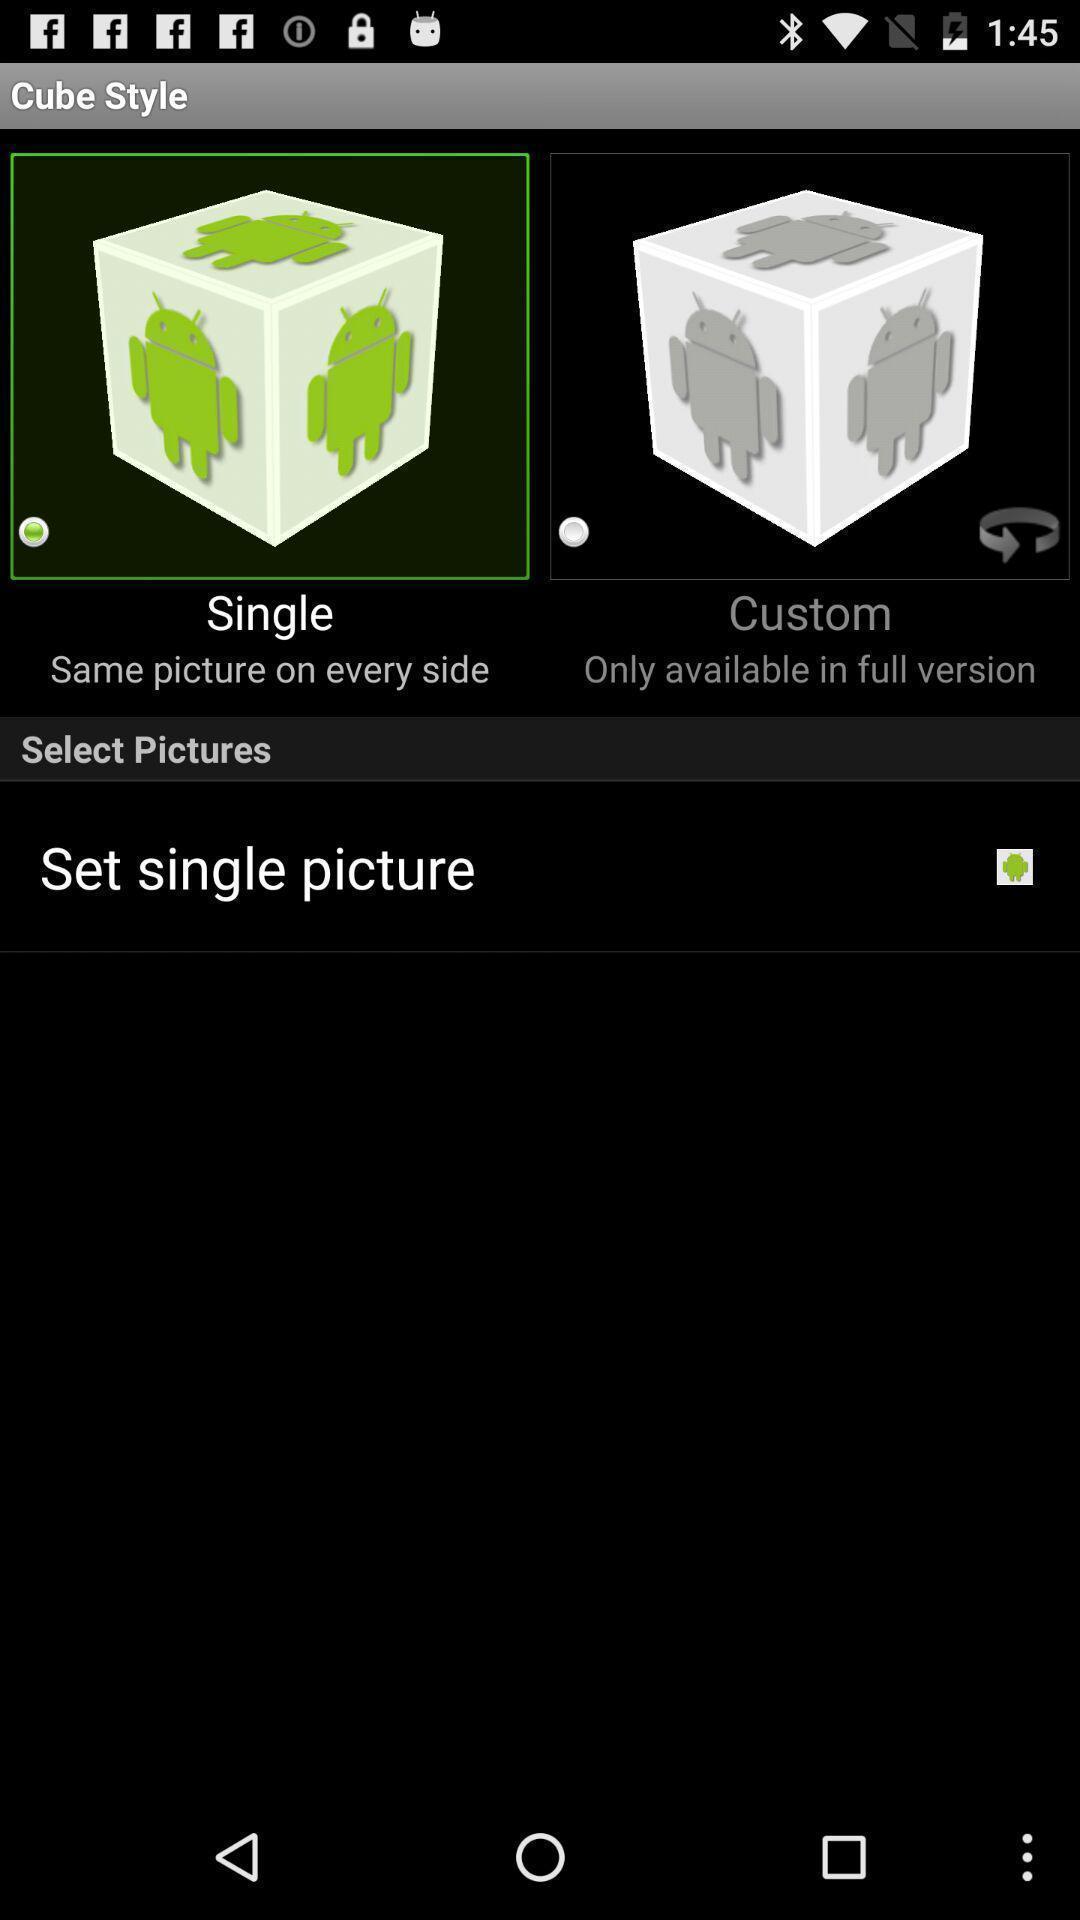Tell me about the visual elements in this screen capture. Window displaying to set the picture. 